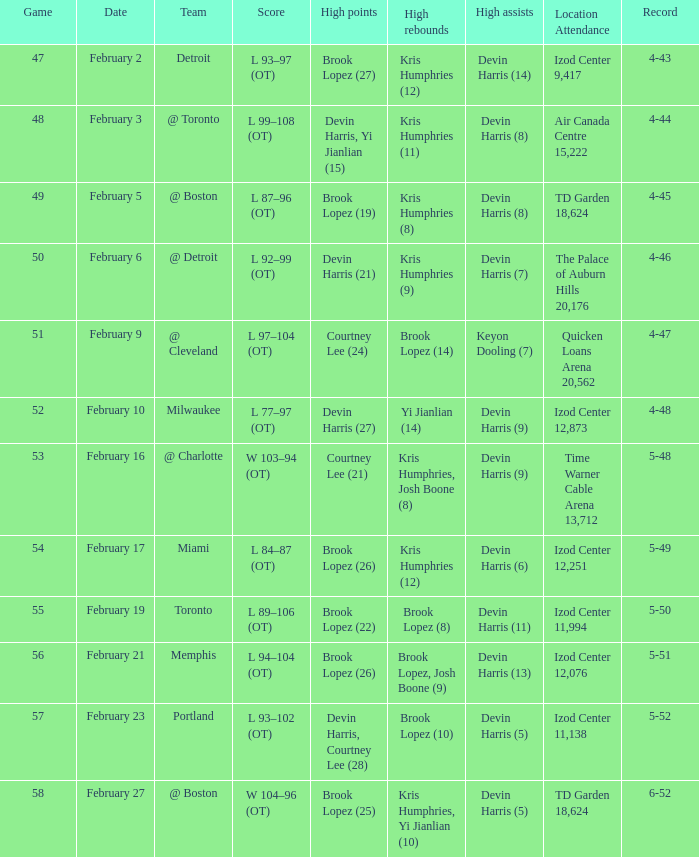What was the record in the game against Memphis? 5-51. 